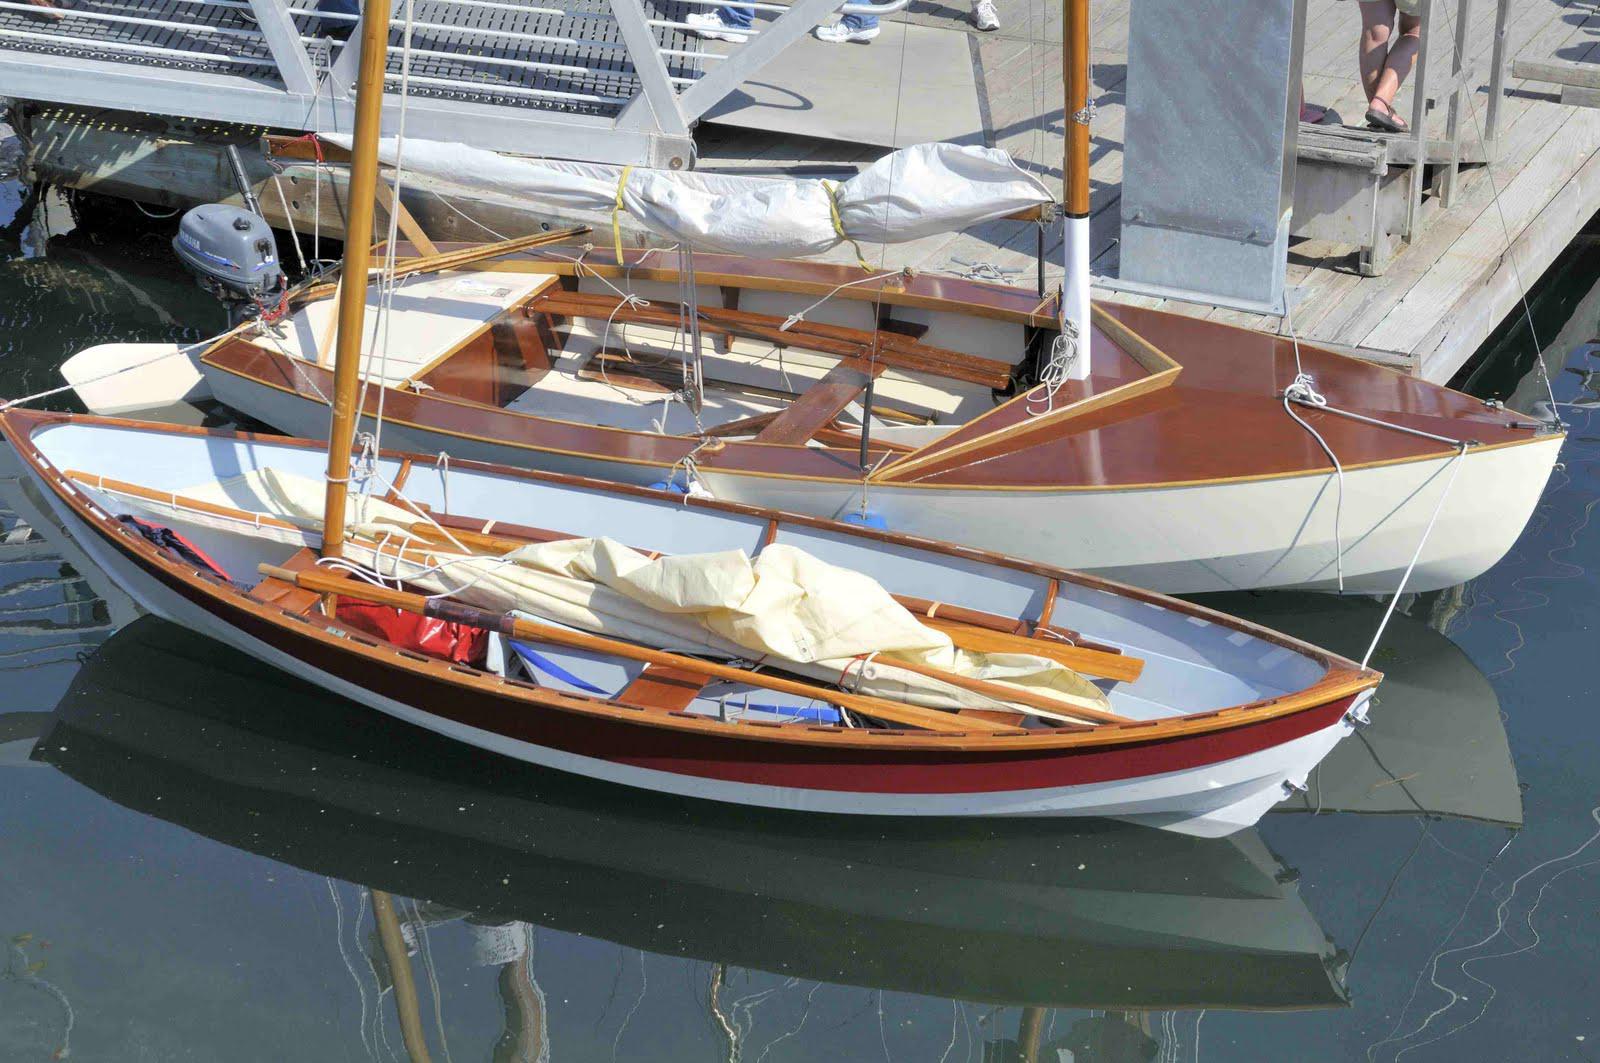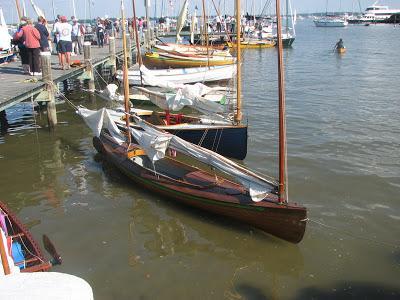The first image is the image on the left, the second image is the image on the right. For the images shown, is this caption "Boats are parked by a wooden pier." true? Answer yes or no. Yes. 